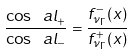Convert formula to latex. <formula><loc_0><loc_0><loc_500><loc_500>\frac { \cos \ a l _ { + } } { \cos \ a l _ { - } } = \frac { f ^ { - } _ { \nu _ { \Gamma } } ( x ) } { f ^ { + } _ { \nu _ { \Gamma } } ( x ) }</formula> 